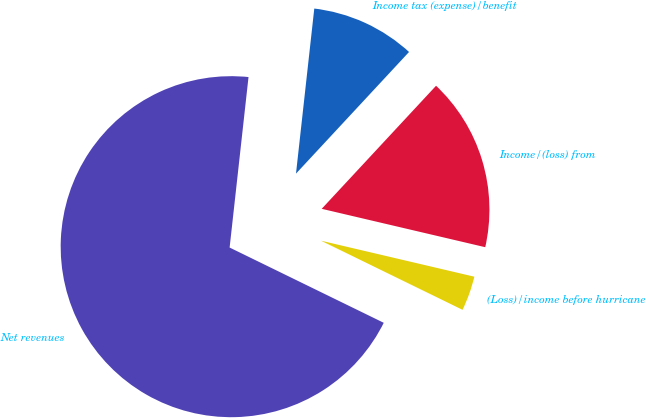Convert chart. <chart><loc_0><loc_0><loc_500><loc_500><pie_chart><fcel>Net revenues<fcel>(Loss)/income before hurricane<fcel>Income/(loss) from<fcel>Income tax (expense)/benefit<nl><fcel>69.52%<fcel>3.56%<fcel>16.75%<fcel>10.16%<nl></chart> 